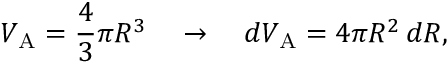<formula> <loc_0><loc_0><loc_500><loc_500>V _ { A } = { \frac { 4 } { 3 } } \pi R ^ { 3 } \quad \rightarrow \quad d V _ { A } = 4 \pi R ^ { 2 } \, d R ,</formula> 